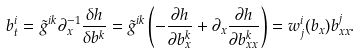<formula> <loc_0><loc_0><loc_500><loc_500>b ^ { i } _ { t } = \tilde { g } ^ { i k } \partial _ { x } ^ { - 1 } \frac { \delta h } { \delta b ^ { k } } = \tilde { g } ^ { i k } \left ( - \frac { \partial h } { \partial b ^ { k } _ { x } } + \partial _ { x } \frac { \partial h } { \partial b ^ { k } _ { x x } } \right ) = w ^ { i } _ { j } ( b _ { x } ) b ^ { j } _ { x x } .</formula> 